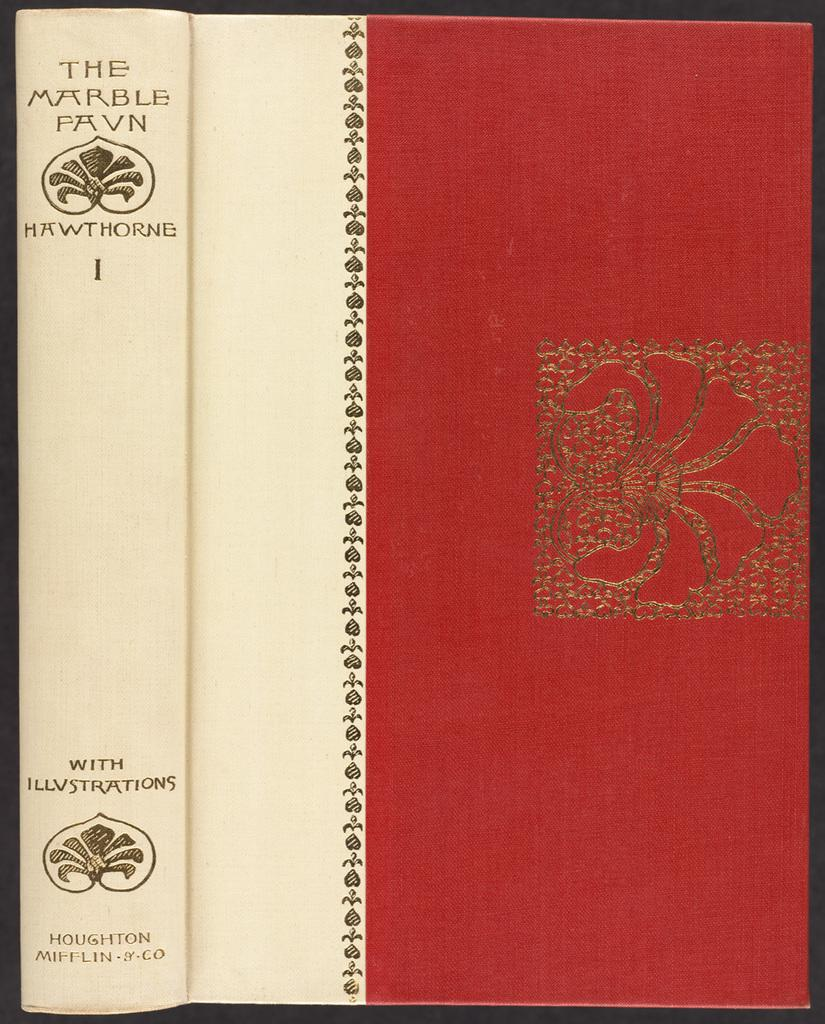<image>
Offer a succinct explanation of the picture presented. A red and white hardback book. On the spine it has text: "With Illustrations" 